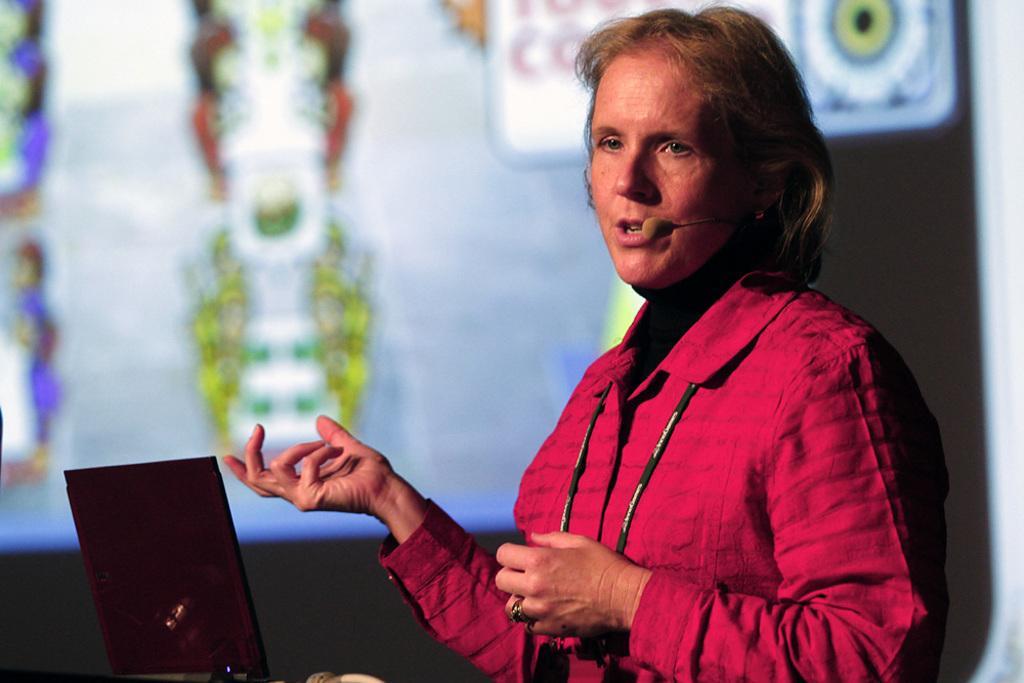Please provide a concise description of this image. In this picture we can see a woman talking on a mic and in front of her we can see a laptop and in the background we can see screen. 